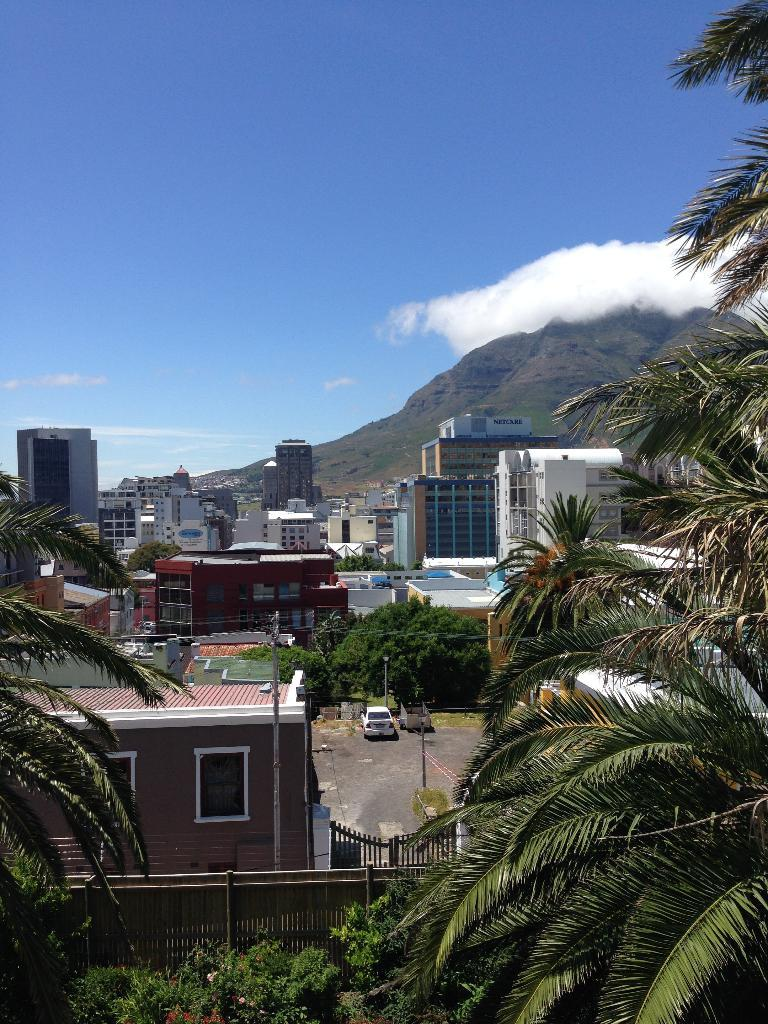What type of structures can be seen in the image? There are buildings in the image. What natural elements are present in the image? There are trees in the image. What man-made objects can be seen in the image? There are poles, a gate, and a fence in the image. What is on the ground in the image? There is a vehicle on the ground in the image. What can be seen in the distance in the image? There are mountains visible in the background of the image, and the sky is cloudy. What type of stick is being used by the root to believe in the image? There is no stick or root present in the image, and the concept of believing is not applicable to the objects shown. 